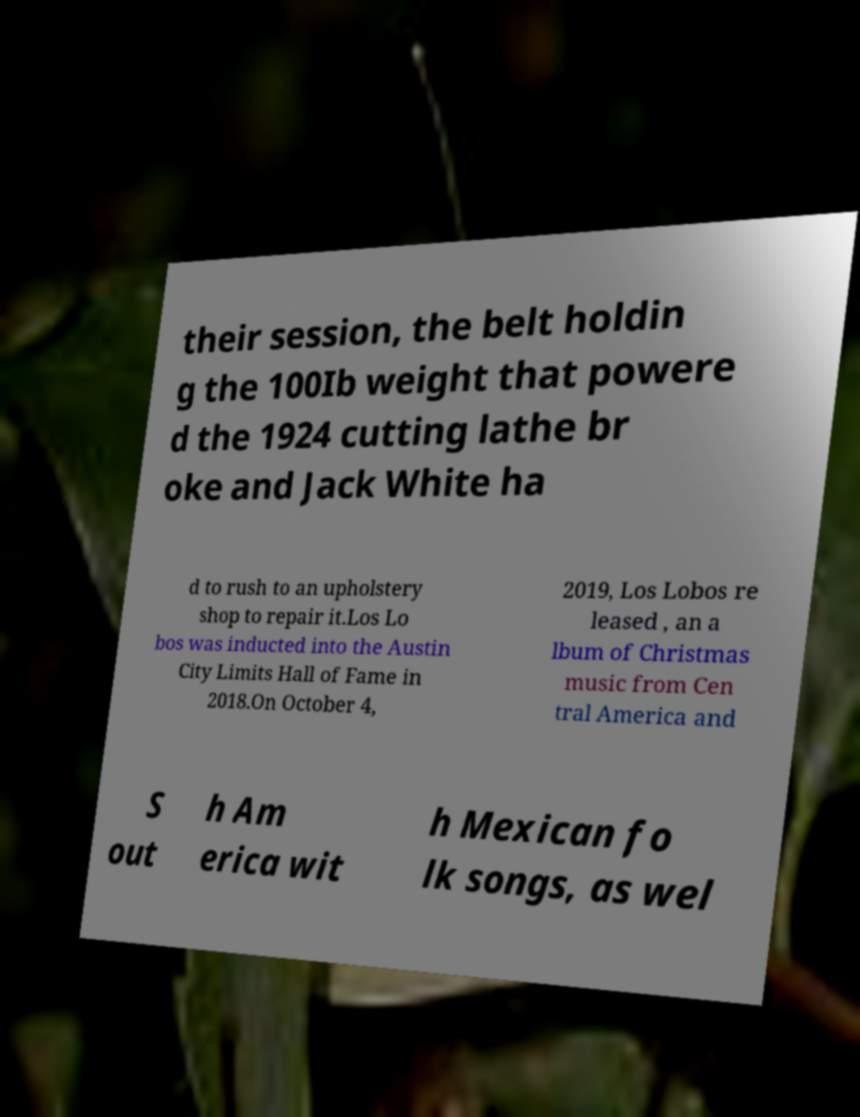Could you assist in decoding the text presented in this image and type it out clearly? their session, the belt holdin g the 100Ib weight that powere d the 1924 cutting lathe br oke and Jack White ha d to rush to an upholstery shop to repair it.Los Lo bos was inducted into the Austin City Limits Hall of Fame in 2018.On October 4, 2019, Los Lobos re leased , an a lbum of Christmas music from Cen tral America and S out h Am erica wit h Mexican fo lk songs, as wel 